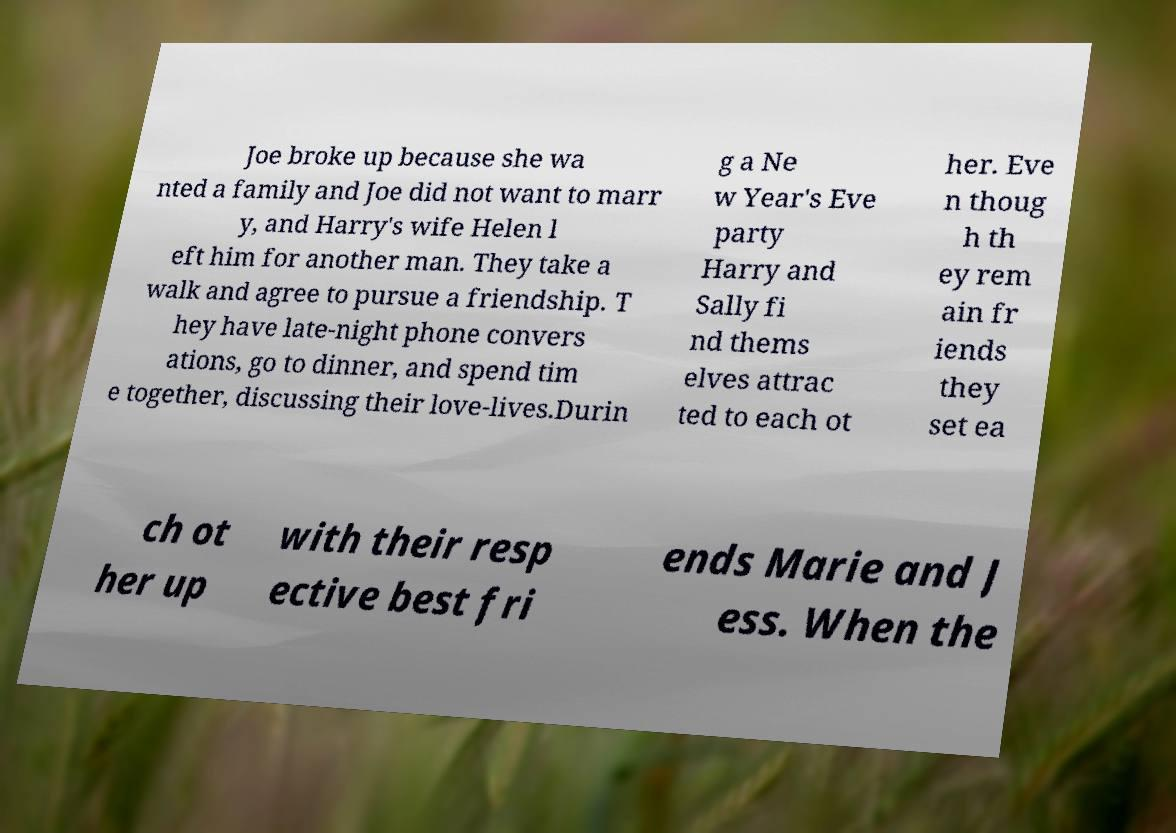Could you assist in decoding the text presented in this image and type it out clearly? Joe broke up because she wa nted a family and Joe did not want to marr y, and Harry's wife Helen l eft him for another man. They take a walk and agree to pursue a friendship. T hey have late-night phone convers ations, go to dinner, and spend tim e together, discussing their love-lives.Durin g a Ne w Year's Eve party Harry and Sally fi nd thems elves attrac ted to each ot her. Eve n thoug h th ey rem ain fr iends they set ea ch ot her up with their resp ective best fri ends Marie and J ess. When the 